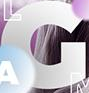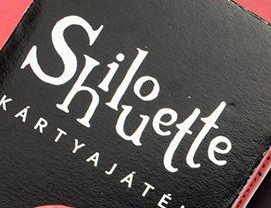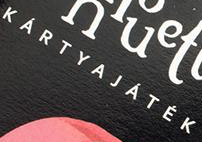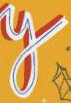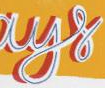Read the text from these images in sequence, separated by a semicolon. G; Shilouette; KÁRTYAJÁTÉK; y; ays 